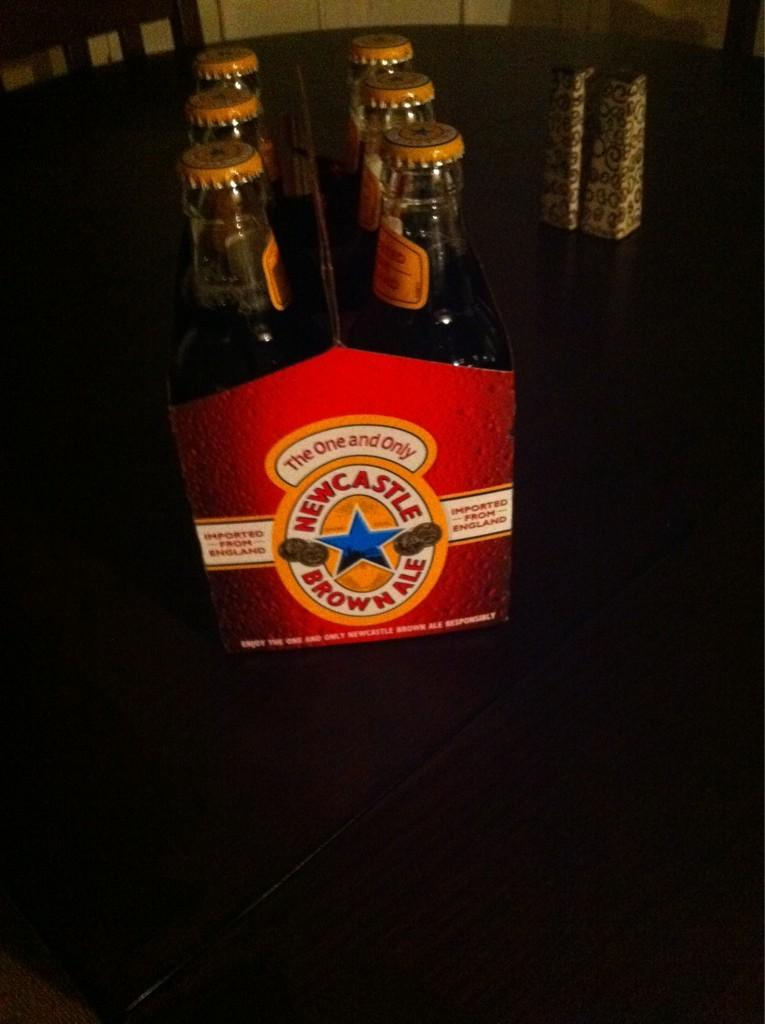<image>
Create a compact narrative representing the image presented. A six back of Newcastle Brown Ale sits on a table. 